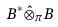<formula> <loc_0><loc_0><loc_500><loc_500>B ^ { * } \hat { \otimes } _ { \pi } B</formula> 